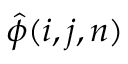<formula> <loc_0><loc_0><loc_500><loc_500>\hat { \phi } ( i , j , n )</formula> 